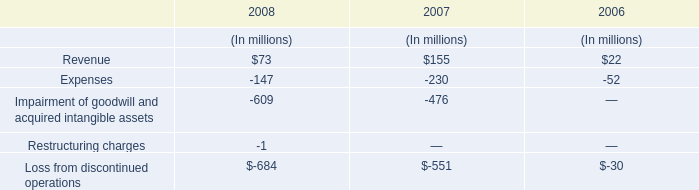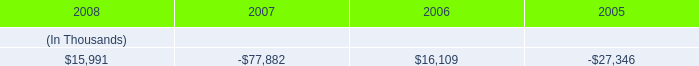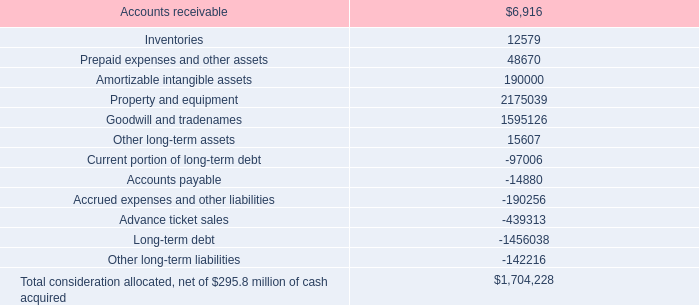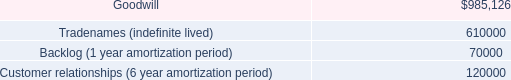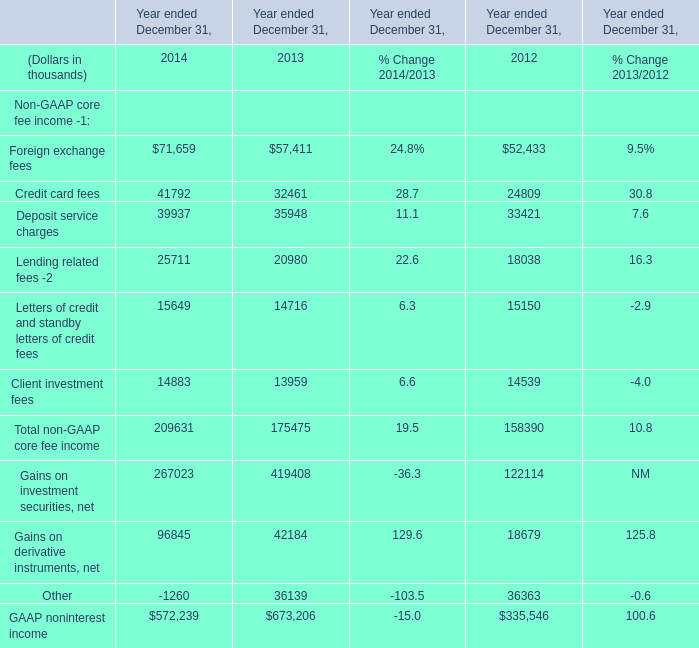In which section the sum of Foreign exchange fees has the highest value? 
Answer: 2014. 